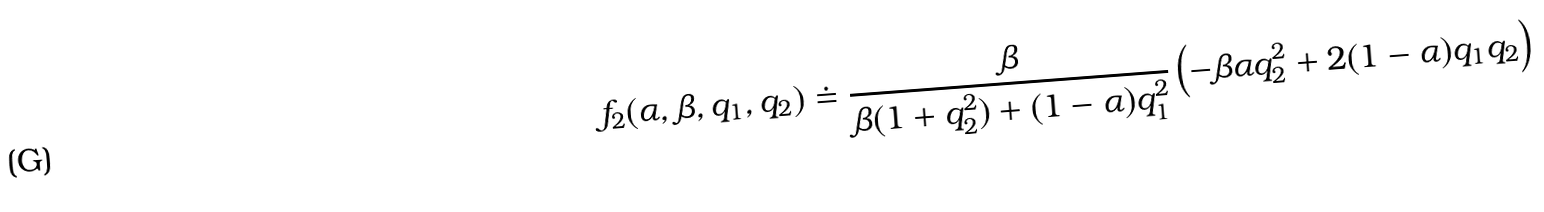<formula> <loc_0><loc_0><loc_500><loc_500>f _ { 2 } ( \alpha , \beta , q _ { 1 } , q _ { 2 } ) \doteq { \frac { \beta } { \beta ( 1 + q _ { 2 } ^ { 2 } ) + ( 1 - \alpha ) q _ { 1 } ^ { 2 } } } \left ( - \beta \alpha q _ { 2 } ^ { 2 } + 2 ( 1 - \alpha ) q _ { 1 } q _ { 2 } \right )</formula> 